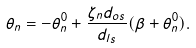<formula> <loc_0><loc_0><loc_500><loc_500>\theta _ { n } = - \theta ^ { 0 } _ { n } + \frac { \zeta _ { n } d _ { o s } } { d _ { l s } } ( \beta + \theta ^ { 0 } _ { n } ) .</formula> 